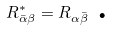<formula> <loc_0><loc_0><loc_500><loc_500>R _ { \bar { \alpha } \beta } ^ { * } = R _ { \alpha \bar { \beta } } \text { .}</formula> 